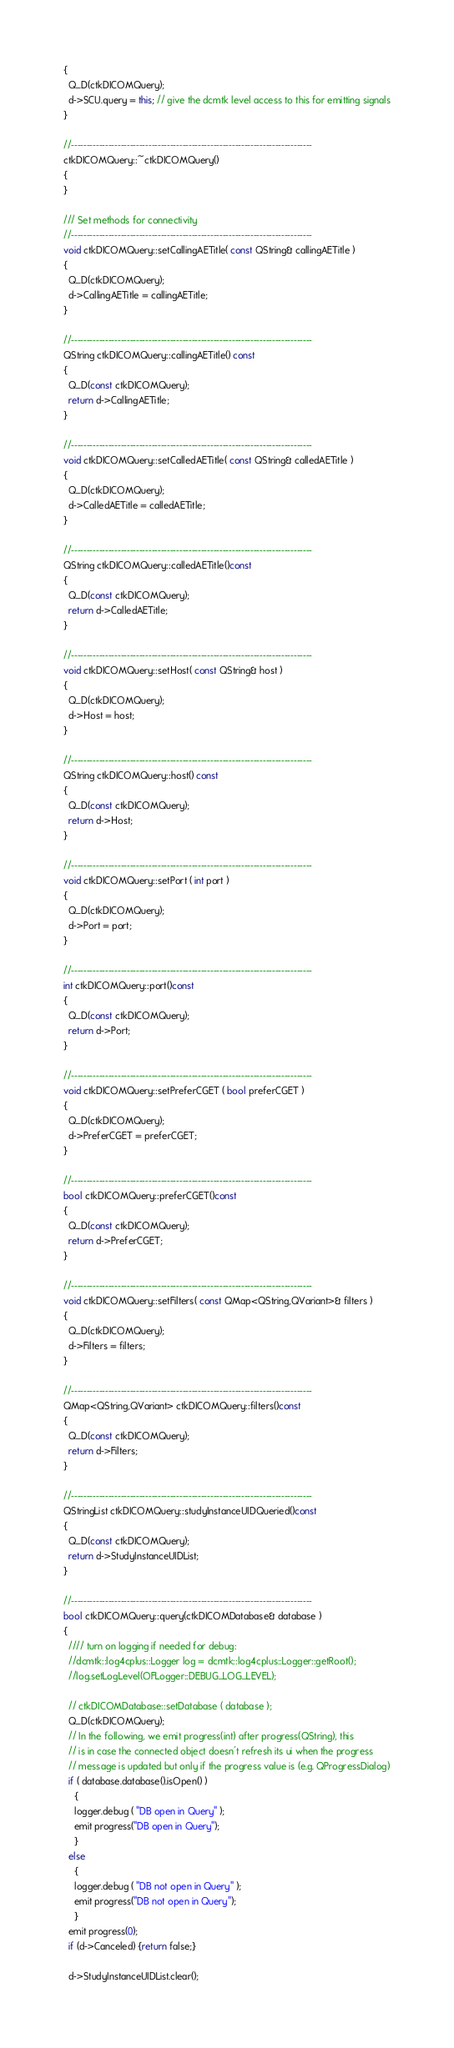<code> <loc_0><loc_0><loc_500><loc_500><_C++_>{
  Q_D(ctkDICOMQuery);
  d->SCU.query = this; // give the dcmtk level access to this for emitting signals
}

//------------------------------------------------------------------------------
ctkDICOMQuery::~ctkDICOMQuery()
{
}

/// Set methods for connectivity
//------------------------------------------------------------------------------
void ctkDICOMQuery::setCallingAETitle( const QString& callingAETitle )
{
  Q_D(ctkDICOMQuery);
  d->CallingAETitle = callingAETitle;
}

//------------------------------------------------------------------------------
QString ctkDICOMQuery::callingAETitle() const
{
  Q_D(const ctkDICOMQuery);
  return d->CallingAETitle;
}

//------------------------------------------------------------------------------
void ctkDICOMQuery::setCalledAETitle( const QString& calledAETitle )
{
  Q_D(ctkDICOMQuery);
  d->CalledAETitle = calledAETitle;
}

//------------------------------------------------------------------------------
QString ctkDICOMQuery::calledAETitle()const
{
  Q_D(const ctkDICOMQuery);
  return d->CalledAETitle;
}

//------------------------------------------------------------------------------
void ctkDICOMQuery::setHost( const QString& host )
{
  Q_D(ctkDICOMQuery);
  d->Host = host;
}

//------------------------------------------------------------------------------
QString ctkDICOMQuery::host() const
{
  Q_D(const ctkDICOMQuery);
  return d->Host;
}

//------------------------------------------------------------------------------
void ctkDICOMQuery::setPort ( int port )
{
  Q_D(ctkDICOMQuery);
  d->Port = port;
}

//------------------------------------------------------------------------------
int ctkDICOMQuery::port()const
{
  Q_D(const ctkDICOMQuery);
  return d->Port;
}

//------------------------------------------------------------------------------
void ctkDICOMQuery::setPreferCGET ( bool preferCGET )
{
  Q_D(ctkDICOMQuery);
  d->PreferCGET = preferCGET;
}

//------------------------------------------------------------------------------
bool ctkDICOMQuery::preferCGET()const
{
  Q_D(const ctkDICOMQuery);
  return d->PreferCGET;
}

//------------------------------------------------------------------------------
void ctkDICOMQuery::setFilters( const QMap<QString,QVariant>& filters )
{
  Q_D(ctkDICOMQuery);
  d->Filters = filters;
}

//------------------------------------------------------------------------------
QMap<QString,QVariant> ctkDICOMQuery::filters()const
{
  Q_D(const ctkDICOMQuery);
  return d->Filters;
}

//------------------------------------------------------------------------------
QStringList ctkDICOMQuery::studyInstanceUIDQueried()const
{
  Q_D(const ctkDICOMQuery);
  return d->StudyInstanceUIDList;
}

//------------------------------------------------------------------------------
bool ctkDICOMQuery::query(ctkDICOMDatabase& database )
{
  //// turn on logging if needed for debug:
  //dcmtk::log4cplus::Logger log = dcmtk::log4cplus::Logger::getRoot();
  //log.setLogLevel(OFLogger::DEBUG_LOG_LEVEL);

  // ctkDICOMDatabase::setDatabase ( database );
  Q_D(ctkDICOMQuery);
  // In the following, we emit progress(int) after progress(QString), this
  // is in case the connected object doesn't refresh its ui when the progress
  // message is updated but only if the progress value is (e.g. QProgressDialog)
  if ( database.database().isOpen() )
    {
    logger.debug ( "DB open in Query" );
    emit progress("DB open in Query");
    }
  else
    {
    logger.debug ( "DB not open in Query" );
    emit progress("DB not open in Query");
    }
  emit progress(0);
  if (d->Canceled) {return false;}

  d->StudyInstanceUIDList.clear();</code> 